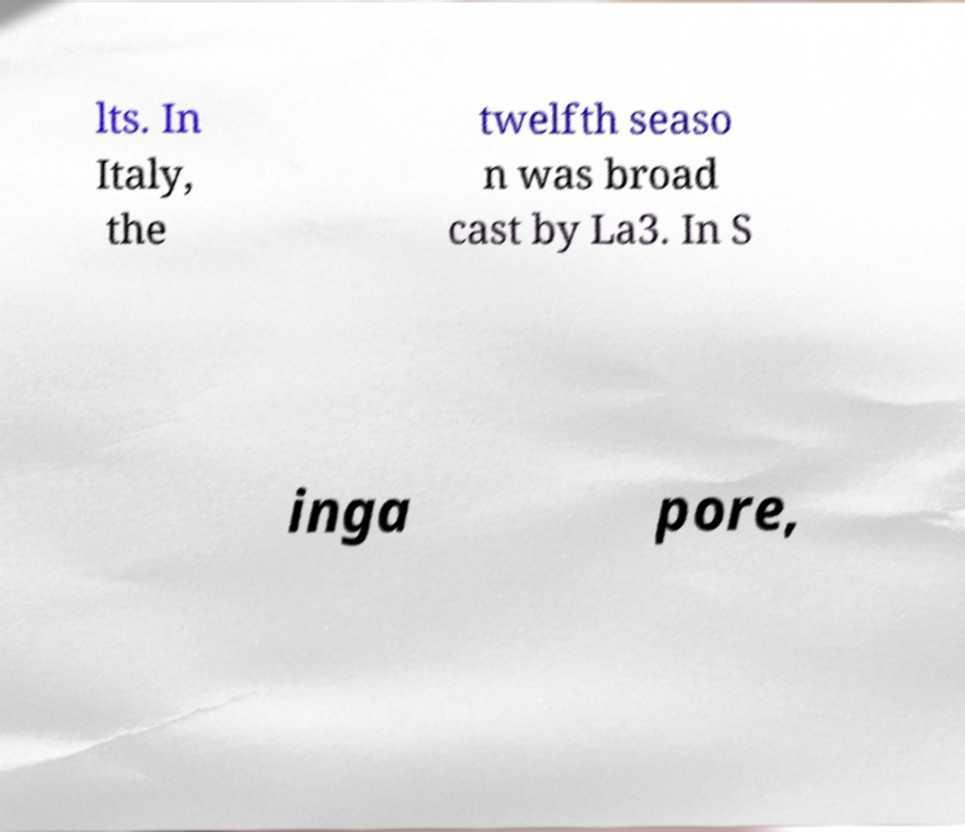Could you extract and type out the text from this image? lts. In Italy, the twelfth seaso n was broad cast by La3. In S inga pore, 